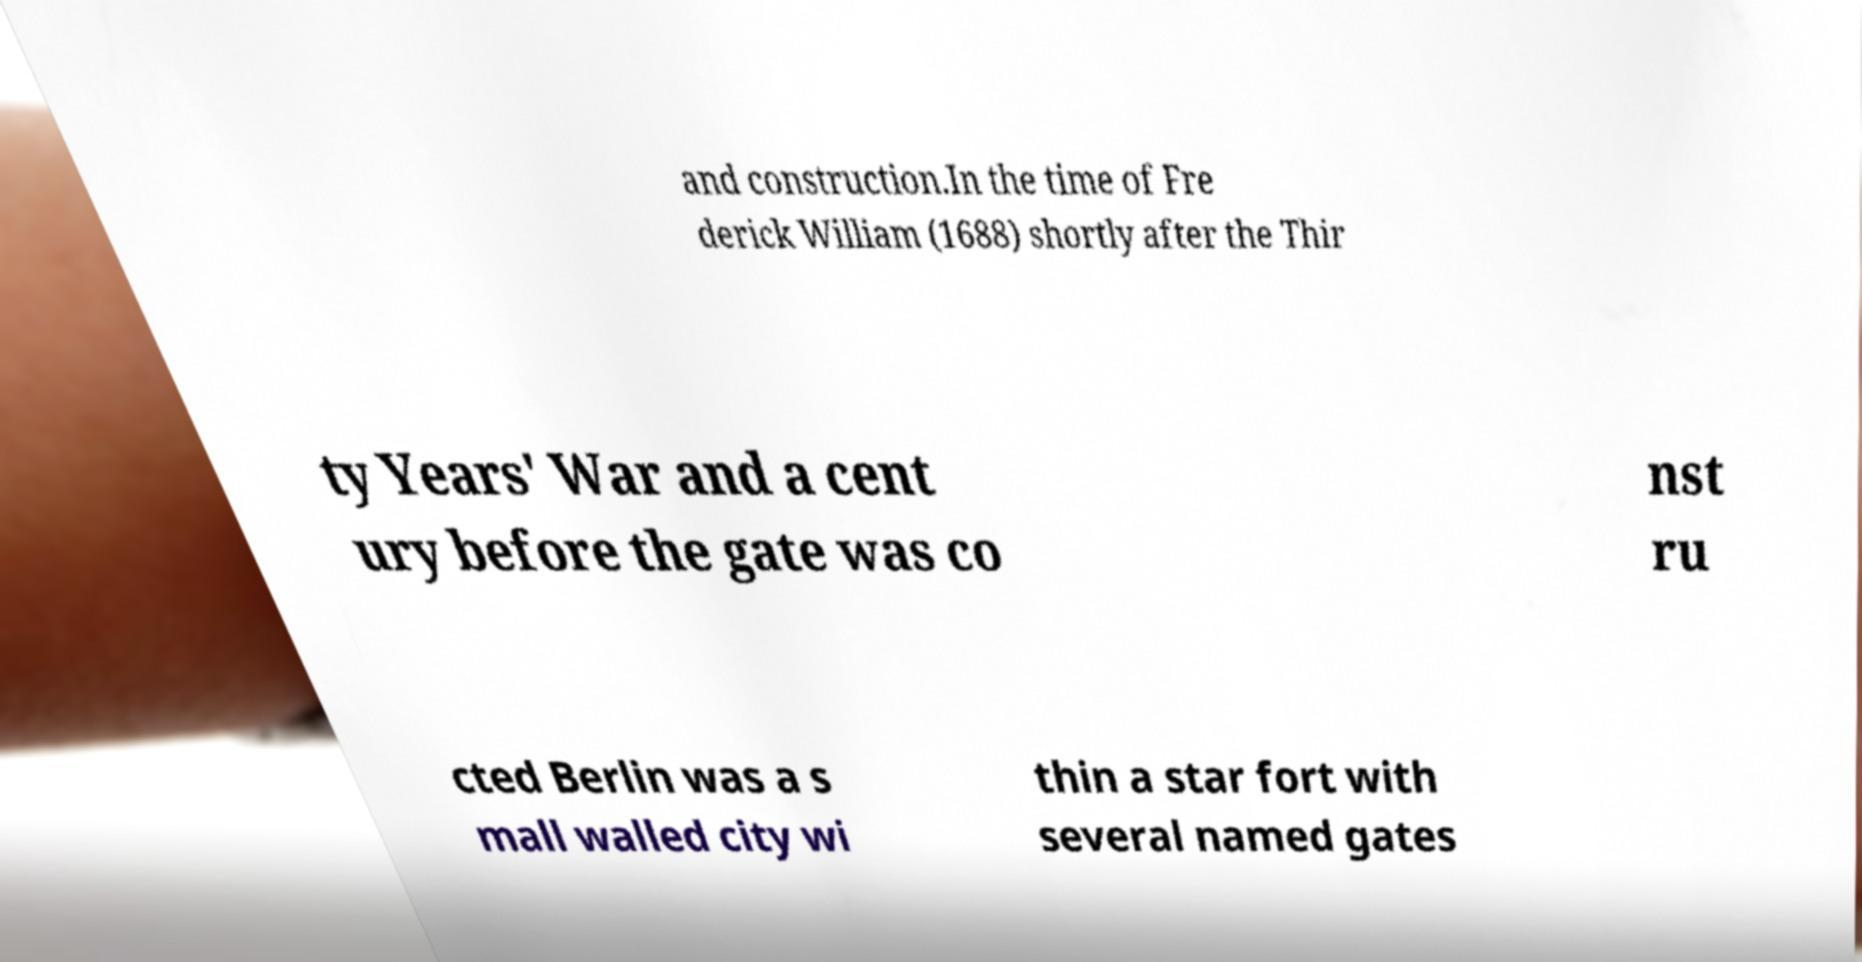Can you read and provide the text displayed in the image?This photo seems to have some interesting text. Can you extract and type it out for me? and construction.In the time of Fre derick William (1688) shortly after the Thir ty Years' War and a cent ury before the gate was co nst ru cted Berlin was a s mall walled city wi thin a star fort with several named gates 